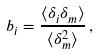<formula> <loc_0><loc_0><loc_500><loc_500>b _ { i } = \frac { \langle \delta _ { i } \delta _ { m } \rangle } { \langle \delta _ { m } ^ { 2 } \rangle } \, ,</formula> 